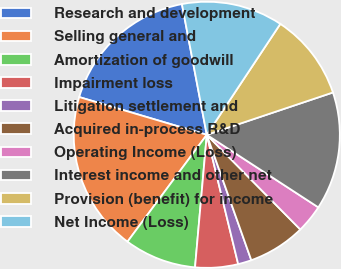Convert chart to OTSL. <chart><loc_0><loc_0><loc_500><loc_500><pie_chart><fcel>Research and development<fcel>Selling general and<fcel>Amortization of goodwill<fcel>Impairment loss<fcel>Litigation settlement and<fcel>Acquired in-process R&D<fcel>Operating Income (Loss)<fcel>Interest income and other net<fcel>Provision (benefit) for income<fcel>Net Income (Loss)<nl><fcel>17.43%<fcel>19.42%<fcel>8.75%<fcel>5.2%<fcel>1.64%<fcel>6.97%<fcel>3.42%<fcel>14.33%<fcel>10.53%<fcel>12.31%<nl></chart> 